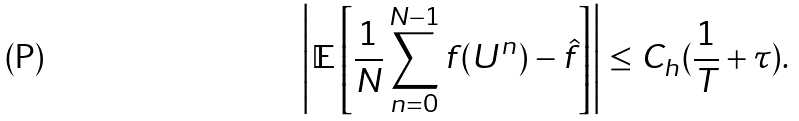<formula> <loc_0><loc_0><loc_500><loc_500>\left | \mathbb { E } \left [ \frac { 1 } { N } \sum _ { n = 0 } ^ { N - 1 } f ( U ^ { n } ) - \hat { f } \right ] \right | \leq C _ { h } ( \frac { 1 } { T } + \tau ) .</formula> 